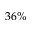<formula> <loc_0><loc_0><loc_500><loc_500>3 6 \%</formula> 